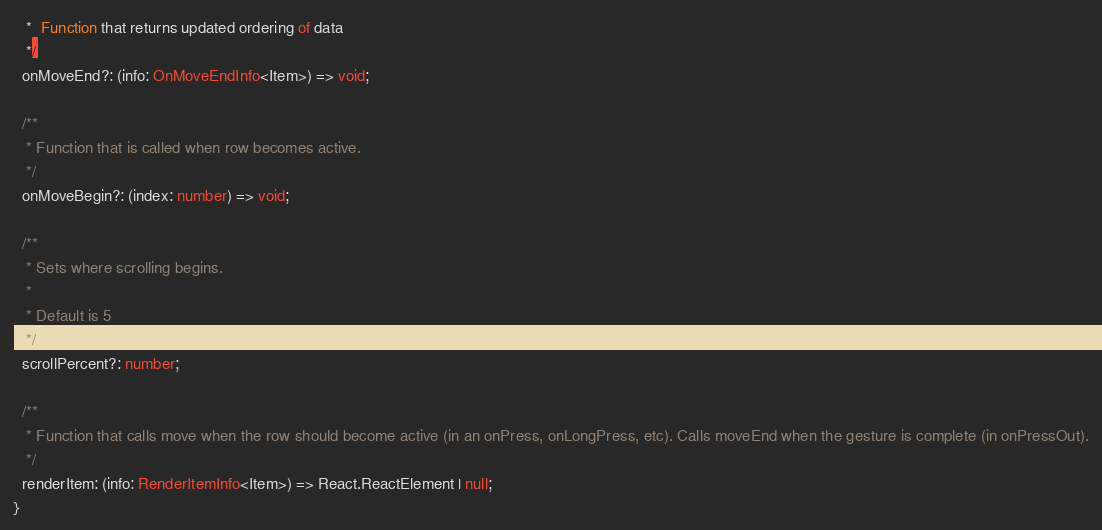<code> <loc_0><loc_0><loc_500><loc_500><_TypeScript_>   *  Function that returns updated ordering of data
   */
  onMoveEnd?: (info: OnMoveEndInfo<Item>) => void;

  /**
   * Function that is called when row becomes active.
   */
  onMoveBegin?: (index: number) => void;

  /**
   * Sets where scrolling begins.
   *
   * Default is 5
   */
  scrollPercent?: number;

  /**
   * Function that calls move when the row should become active (in an onPress, onLongPress, etc). Calls moveEnd when the gesture is complete (in onPressOut).
   */
  renderItem: (info: RenderItemInfo<Item>) => React.ReactElement | null;
}
</code> 